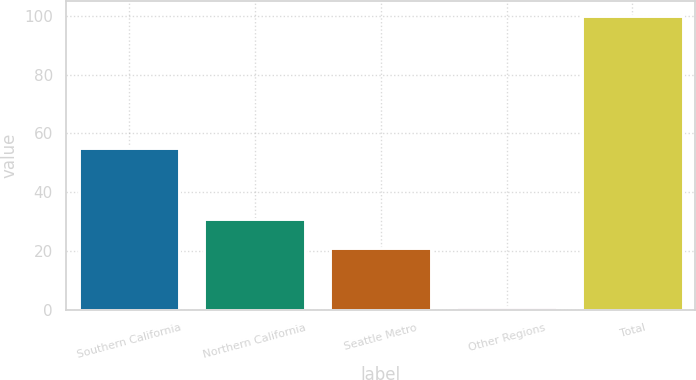Convert chart. <chart><loc_0><loc_0><loc_500><loc_500><bar_chart><fcel>Southern California<fcel>Northern California<fcel>Seattle Metro<fcel>Other Regions<fcel>Total<nl><fcel>55<fcel>30.9<fcel>21<fcel>1<fcel>100<nl></chart> 